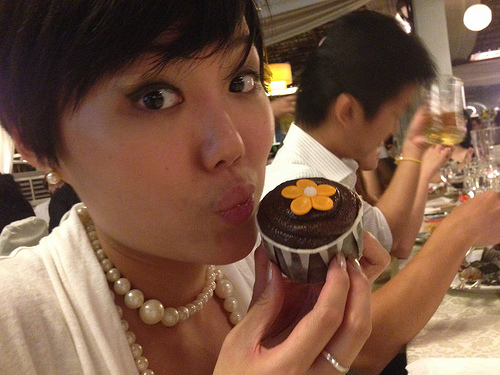What can you infer about the setting based on the background elements? Based on the background elements like the dining setup and the presence of people enjoying food and drinks, it appears to be a social gathering in a restaurant or a festive event. What could be a possible dialogue happening among the people in the background? It is possible that the people in the background are engaged in light-hearted conversations, discussing their meals, sharing stories, and enjoying each other's company. They might be talking about the desserts, the event they are attending, or reminiscing about past encounters. 